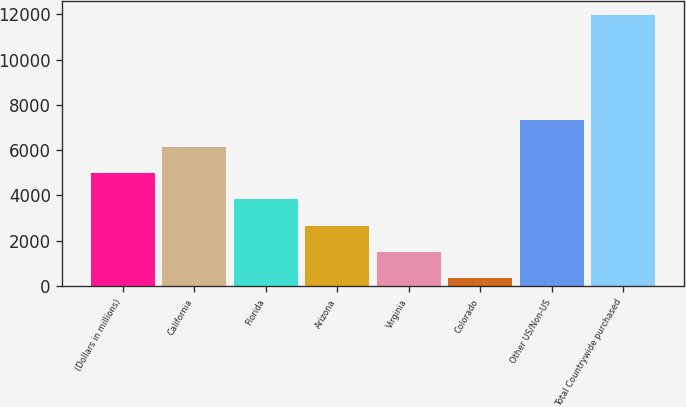<chart> <loc_0><loc_0><loc_500><loc_500><bar_chart><fcel>(Dollars in millions)<fcel>California<fcel>Florida<fcel>Arizona<fcel>Virginia<fcel>Colorado<fcel>Other US/Non-US<fcel>Total Countrywide purchased<nl><fcel>4993.4<fcel>6157.5<fcel>3829.3<fcel>2665.2<fcel>1501.1<fcel>337<fcel>7321.6<fcel>11978<nl></chart> 